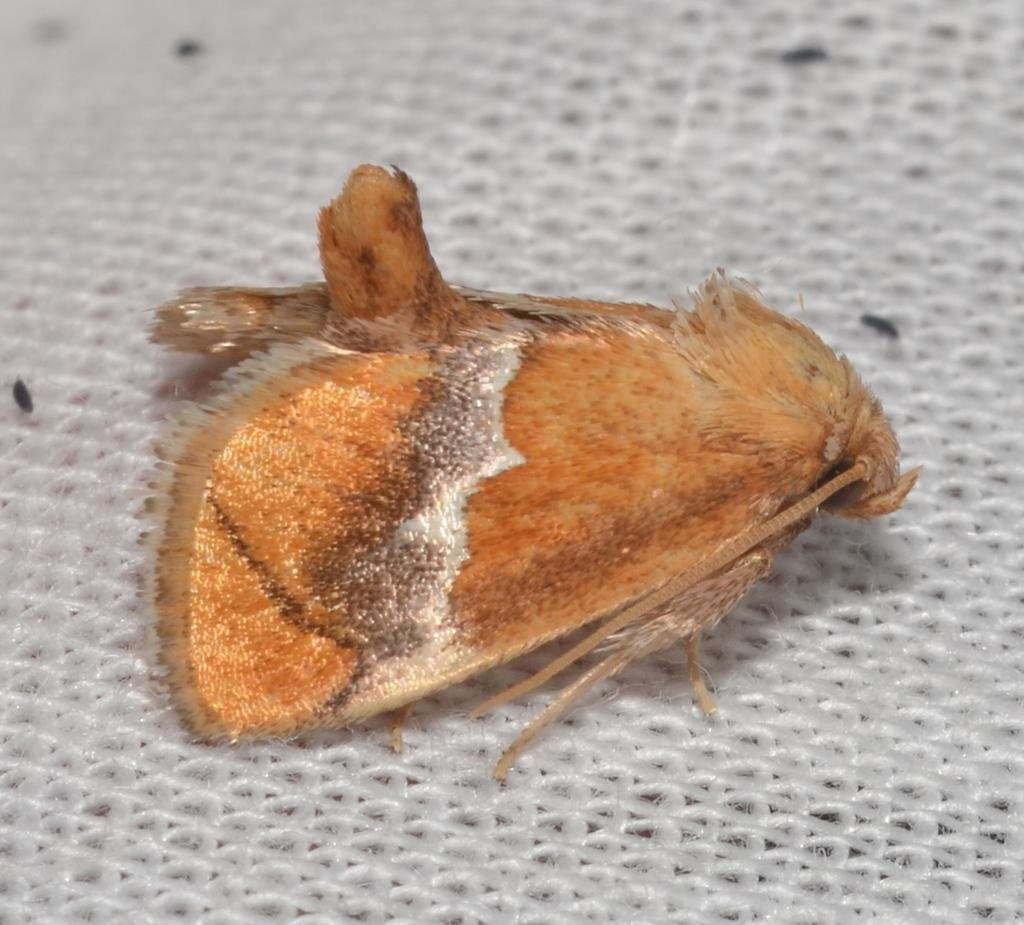What is present in the picture? There is a fly in the picture. Can you describe the appearance of the fly? The fly is white and brown in color. What is the color of the background in the picture? The background of the picture is white. How many flowers are blooming on the wall in the image? There are no flowers or walls present in the image; it features a fly with a white and brown coloration against a white background. 